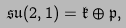Convert formula to latex. <formula><loc_0><loc_0><loc_500><loc_500>\mathfrak { s u } ( 2 , 1 ) = \mathfrak { k } \oplus \mathfrak { p } ,</formula> 